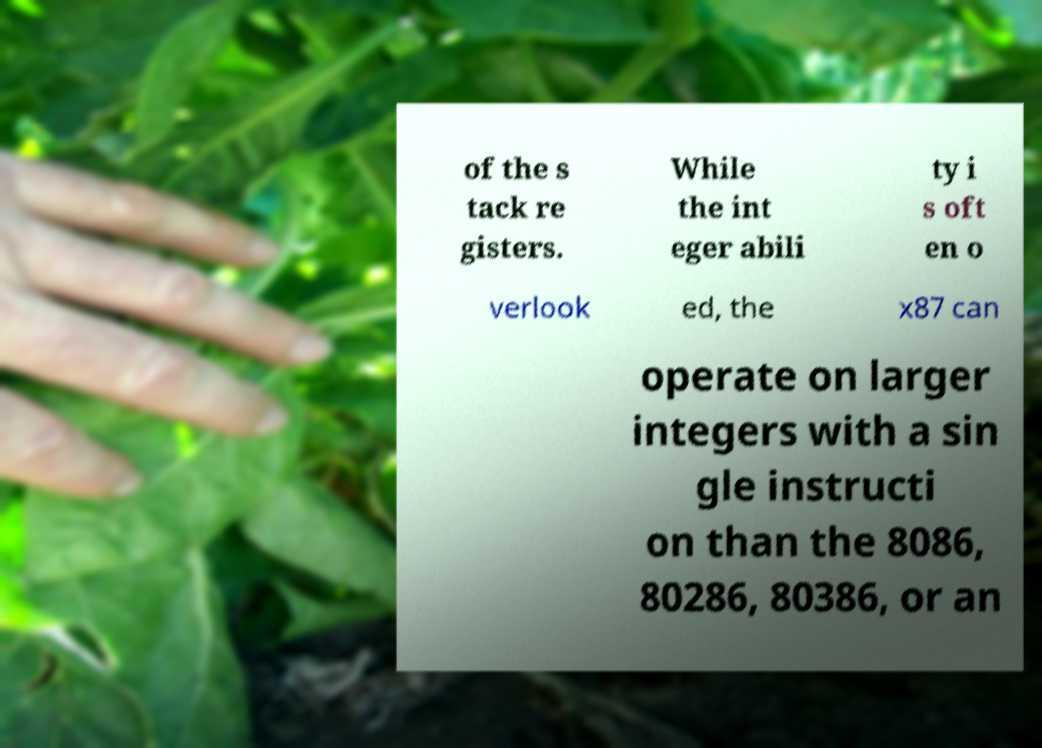There's text embedded in this image that I need extracted. Can you transcribe it verbatim? of the s tack re gisters. While the int eger abili ty i s oft en o verlook ed, the x87 can operate on larger integers with a sin gle instructi on than the 8086, 80286, 80386, or an 